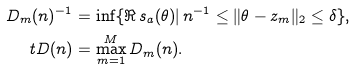Convert formula to latex. <formula><loc_0><loc_0><loc_500><loc_500>D _ { m } ( n ) ^ { - 1 } & = \inf \{ \Re \, s _ { a } ( \theta ) | \, n ^ { - 1 } \leq \| \theta - z _ { m } \| _ { 2 } \leq \delta \} , \\ \ t D ( n ) & = \max _ { m = 1 } ^ { M } D _ { m } ( n ) .</formula> 